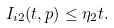Convert formula to latex. <formula><loc_0><loc_0><loc_500><loc_500>I _ { i 2 } ( t , p ) \leq \eta _ { 2 } t .</formula> 